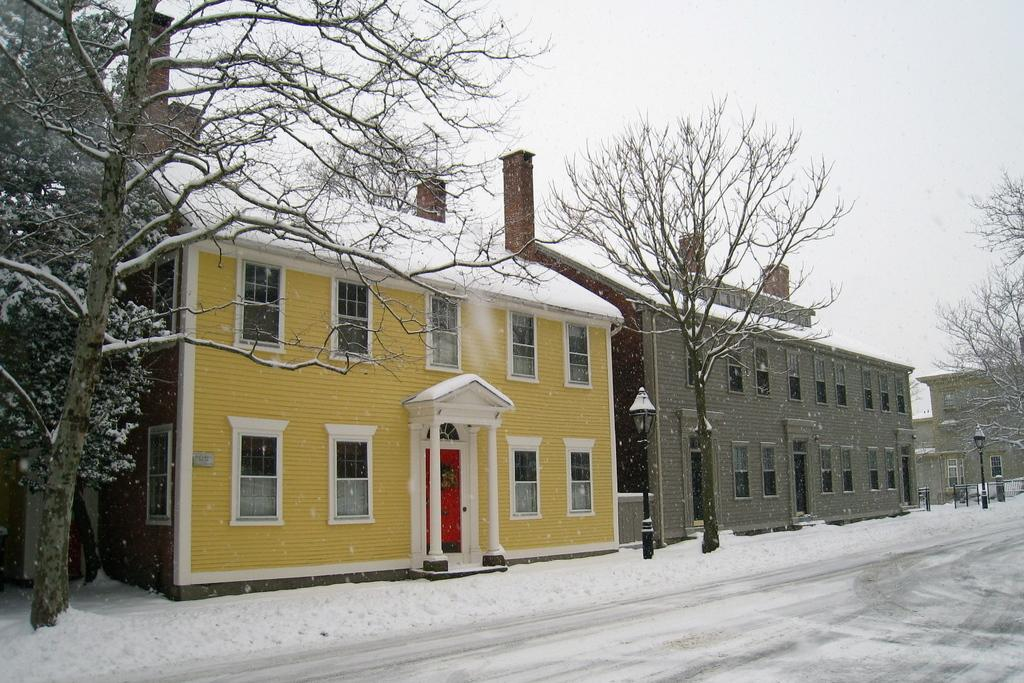What is the main feature of the image? There is a road in the image. What can be seen near the road? Trees and street light poles are near the road. Can you describe the buildings in the image? The buildings have windows, pillars, and doors. How does the weather appear in the image? The image is covered with snow. What type of government is depicted in the image? There is no depiction of a government in the image; it primarily features a road, trees, street light poles, buildings, and snow. Can you see the sea in the image? No, the sea is not visible in the image; it focuses on a road, trees, street light poles, buildings, and snow. 